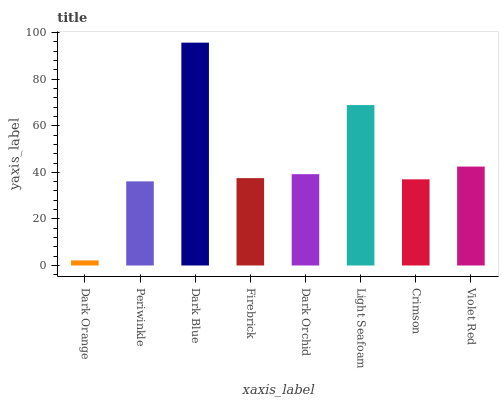Is Dark Orange the minimum?
Answer yes or no. Yes. Is Dark Blue the maximum?
Answer yes or no. Yes. Is Periwinkle the minimum?
Answer yes or no. No. Is Periwinkle the maximum?
Answer yes or no. No. Is Periwinkle greater than Dark Orange?
Answer yes or no. Yes. Is Dark Orange less than Periwinkle?
Answer yes or no. Yes. Is Dark Orange greater than Periwinkle?
Answer yes or no. No. Is Periwinkle less than Dark Orange?
Answer yes or no. No. Is Dark Orchid the high median?
Answer yes or no. Yes. Is Firebrick the low median?
Answer yes or no. Yes. Is Firebrick the high median?
Answer yes or no. No. Is Crimson the low median?
Answer yes or no. No. 